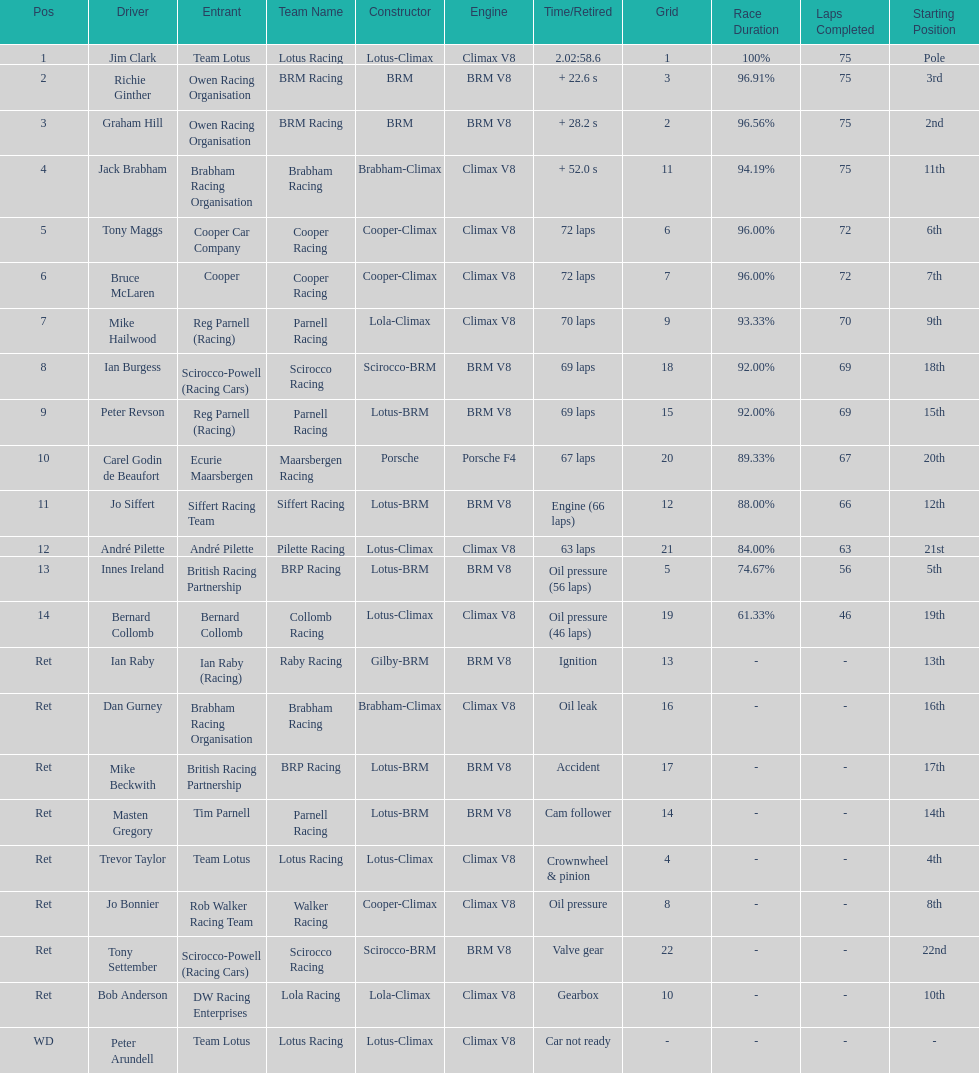How many racers had cooper-climax as their constructor? 3. Could you help me parse every detail presented in this table? {'header': ['Pos', 'Driver', 'Entrant', 'Team Name', 'Constructor', 'Engine', 'Time/Retired', 'Grid', 'Race Duration', 'Laps Completed', 'Starting Position'], 'rows': [['1', 'Jim Clark', 'Team Lotus', 'Lotus Racing', 'Lotus-Climax', 'Climax V8', '2.02:58.6', '1', '100%', '75', 'Pole'], ['2', 'Richie Ginther', 'Owen Racing Organisation', 'BRM Racing', 'BRM', 'BRM V8', '+ 22.6 s', '3', '96.91%', '75', '3rd'], ['3', 'Graham Hill', 'Owen Racing Organisation', 'BRM Racing', 'BRM', 'BRM V8', '+ 28.2 s', '2', '96.56%', '75', '2nd'], ['4', 'Jack Brabham', 'Brabham Racing Organisation', 'Brabham Racing', 'Brabham-Climax', 'Climax V8', '+ 52.0 s', '11', '94.19%', '75', '11th'], ['5', 'Tony Maggs', 'Cooper Car Company', 'Cooper Racing', 'Cooper-Climax', 'Climax V8', '72 laps', '6', '96.00%', '72', '6th'], ['6', 'Bruce McLaren', 'Cooper', 'Cooper Racing', 'Cooper-Climax', 'Climax V8', '72 laps', '7', '96.00%', '72', '7th'], ['7', 'Mike Hailwood', 'Reg Parnell (Racing)', 'Parnell Racing', 'Lola-Climax', 'Climax V8', '70 laps', '9', '93.33%', '70', '9th'], ['8', 'Ian Burgess', 'Scirocco-Powell (Racing Cars)', 'Scirocco Racing', 'Scirocco-BRM', 'BRM V8', '69 laps', '18', '92.00%', '69', '18th'], ['9', 'Peter Revson', 'Reg Parnell (Racing)', 'Parnell Racing', 'Lotus-BRM', 'BRM V8', '69 laps', '15', '92.00%', '69', '15th'], ['10', 'Carel Godin de Beaufort', 'Ecurie Maarsbergen', 'Maarsbergen Racing', 'Porsche', 'Porsche F4', '67 laps', '20', '89.33%', '67', '20th'], ['11', 'Jo Siffert', 'Siffert Racing Team', 'Siffert Racing', 'Lotus-BRM', 'BRM V8', 'Engine (66 laps)', '12', '88.00%', '66', '12th'], ['12', 'André Pilette', 'André Pilette', 'Pilette Racing', 'Lotus-Climax', 'Climax V8', '63 laps', '21', '84.00%', '63', '21st'], ['13', 'Innes Ireland', 'British Racing Partnership', 'BRP Racing', 'Lotus-BRM', 'BRM V8', 'Oil pressure (56 laps)', '5', '74.67%', '56', '5th'], ['14', 'Bernard Collomb', 'Bernard Collomb', 'Collomb Racing', 'Lotus-Climax', 'Climax V8', 'Oil pressure (46 laps)', '19', '61.33%', '46', '19th'], ['Ret', 'Ian Raby', 'Ian Raby (Racing)', 'Raby Racing', 'Gilby-BRM', 'BRM V8', 'Ignition', '13', '-', '-', '13th'], ['Ret', 'Dan Gurney', 'Brabham Racing Organisation', 'Brabham Racing', 'Brabham-Climax', 'Climax V8', 'Oil leak', '16', '-', '-', '16th'], ['Ret', 'Mike Beckwith', 'British Racing Partnership', 'BRP Racing', 'Lotus-BRM', 'BRM V8', 'Accident', '17', '-', '-', '17th'], ['Ret', 'Masten Gregory', 'Tim Parnell', 'Parnell Racing', 'Lotus-BRM', 'BRM V8', 'Cam follower', '14', '-', '-', '14th'], ['Ret', 'Trevor Taylor', 'Team Lotus', 'Lotus Racing', 'Lotus-Climax', 'Climax V8', 'Crownwheel & pinion', '4', '-', '-', '4th'], ['Ret', 'Jo Bonnier', 'Rob Walker Racing Team', 'Walker Racing', 'Cooper-Climax', 'Climax V8', 'Oil pressure', '8', '-', '-', '8th'], ['Ret', 'Tony Settember', 'Scirocco-Powell (Racing Cars)', 'Scirocco Racing', 'Scirocco-BRM', 'BRM V8', 'Valve gear', '22', '-', '-', '22nd'], ['Ret', 'Bob Anderson', 'DW Racing Enterprises', 'Lola Racing', 'Lola-Climax', 'Climax V8', 'Gearbox', '10', '-', '-', '10th'], ['WD', 'Peter Arundell', 'Team Lotus', 'Lotus Racing', 'Lotus-Climax', 'Climax V8', 'Car not ready', '-', '-', '-', '-']]} 